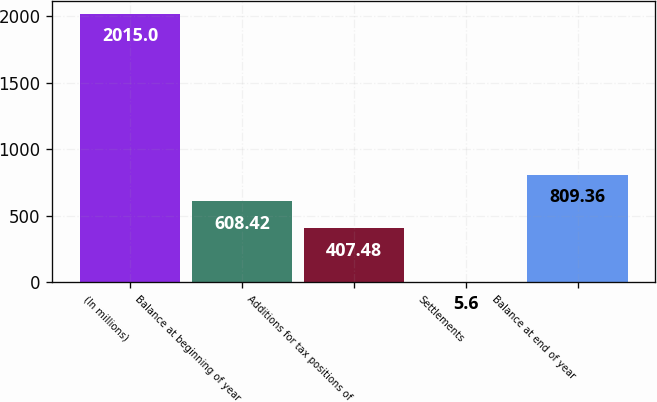<chart> <loc_0><loc_0><loc_500><loc_500><bar_chart><fcel>(In millions)<fcel>Balance at beginning of year<fcel>Additions for tax positions of<fcel>Settlements<fcel>Balance at end of year<nl><fcel>2015<fcel>608.42<fcel>407.48<fcel>5.6<fcel>809.36<nl></chart> 